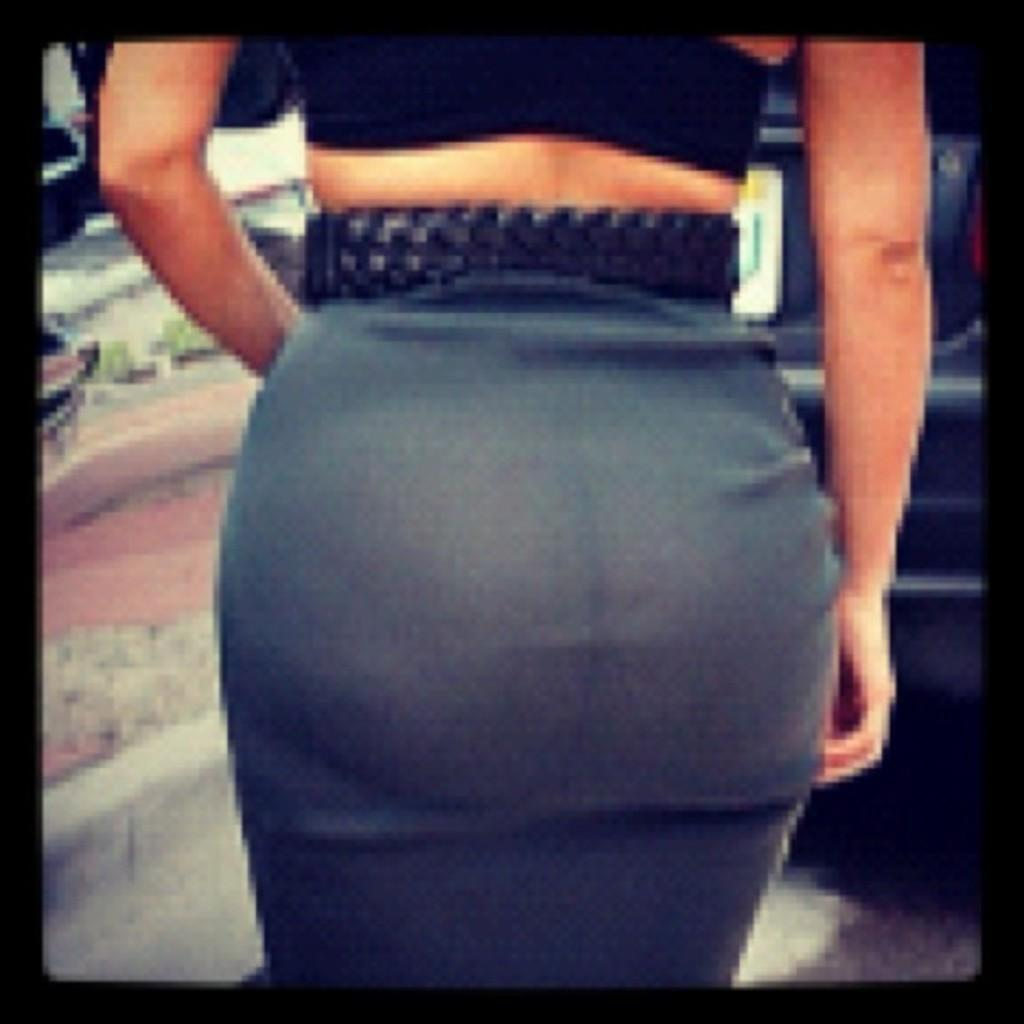Who or what is the main subject of the image? There is a person in the image. Can you describe the background of the image? The background of the image is blurred. What arithmetic problem is the person solving in the image? There is no arithmetic problem visible in the image. What type of cub is the person holding in the image? There is no cub present in the image. 